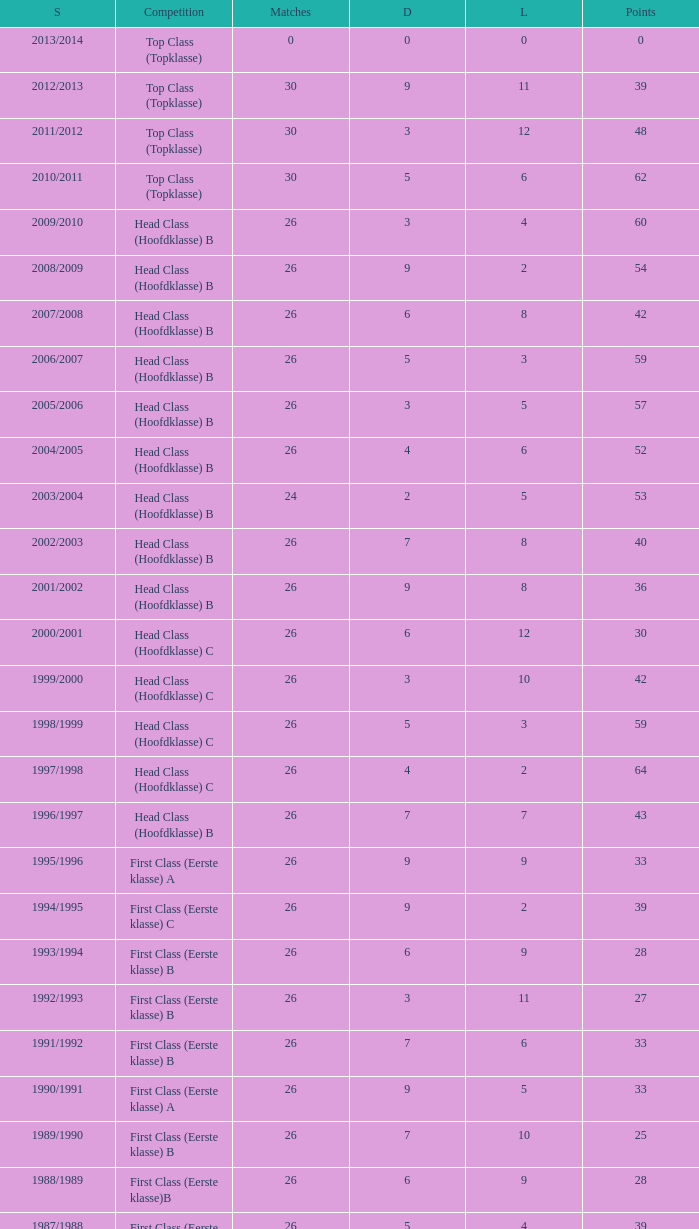What competition has a score greater than 30, a draw less than 5, and a loss larger than 10? Top Class (Topklasse). 